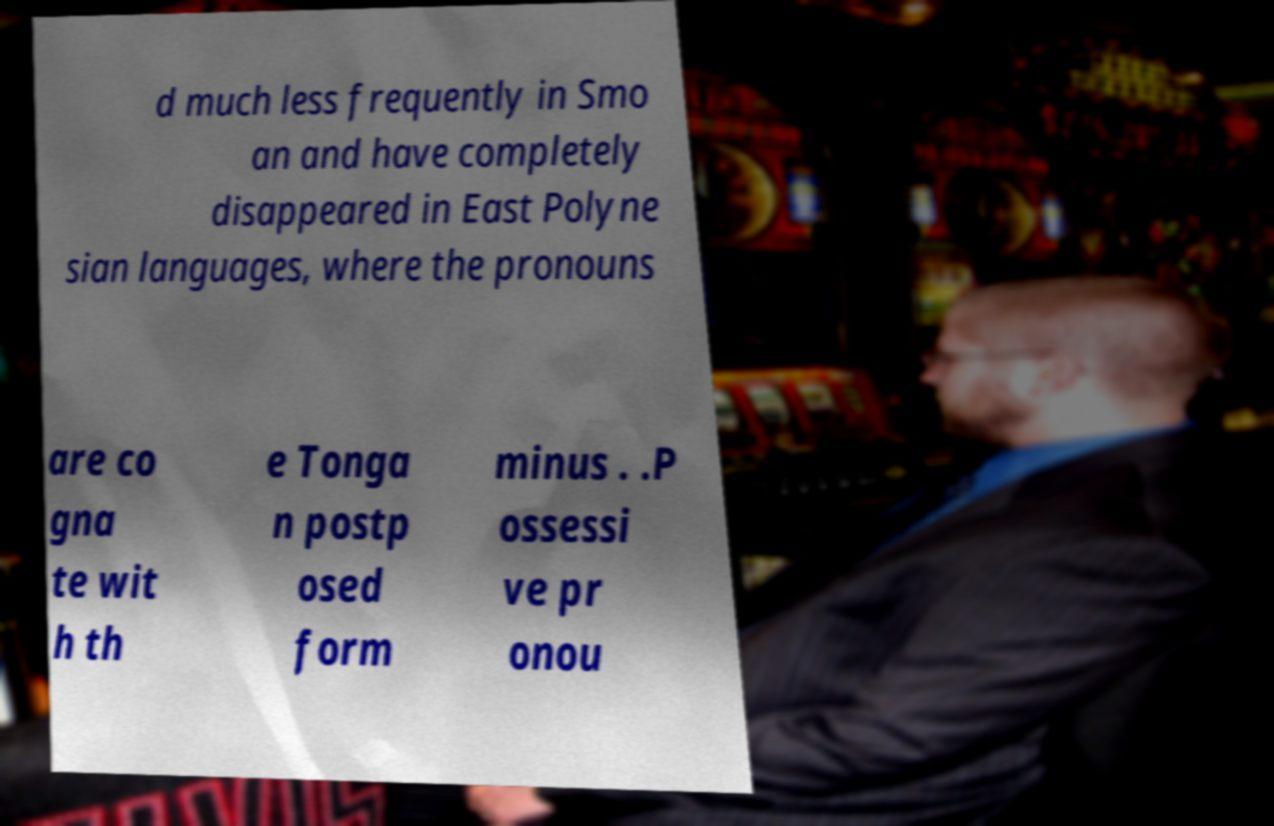Could you assist in decoding the text presented in this image and type it out clearly? d much less frequently in Smo an and have completely disappeared in East Polyne sian languages, where the pronouns are co gna te wit h th e Tonga n postp osed form minus . .P ossessi ve pr onou 